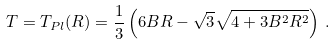<formula> <loc_0><loc_0><loc_500><loc_500>T = T _ { P l } ( R ) = \frac { 1 } { 3 } \left ( 6 B R - \sqrt { 3 } \sqrt { 4 + 3 B ^ { 2 } R ^ { 2 } } \right ) \, .</formula> 